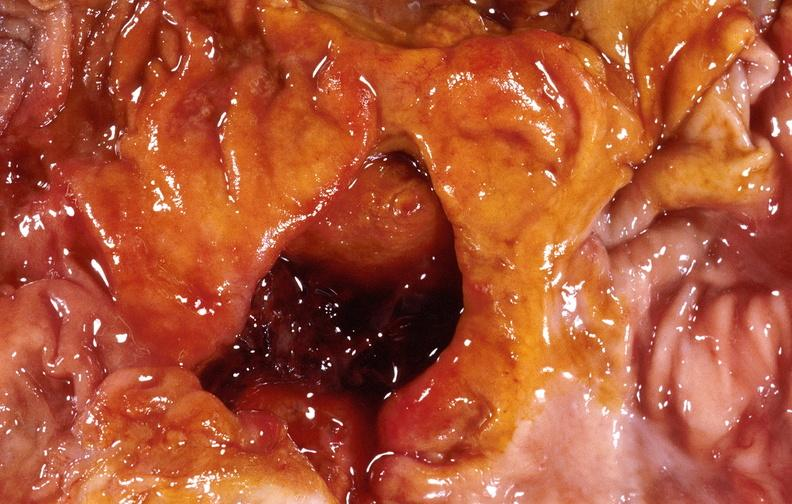what does this image show?
Answer the question using a single word or phrase. Duodenal ulcer 